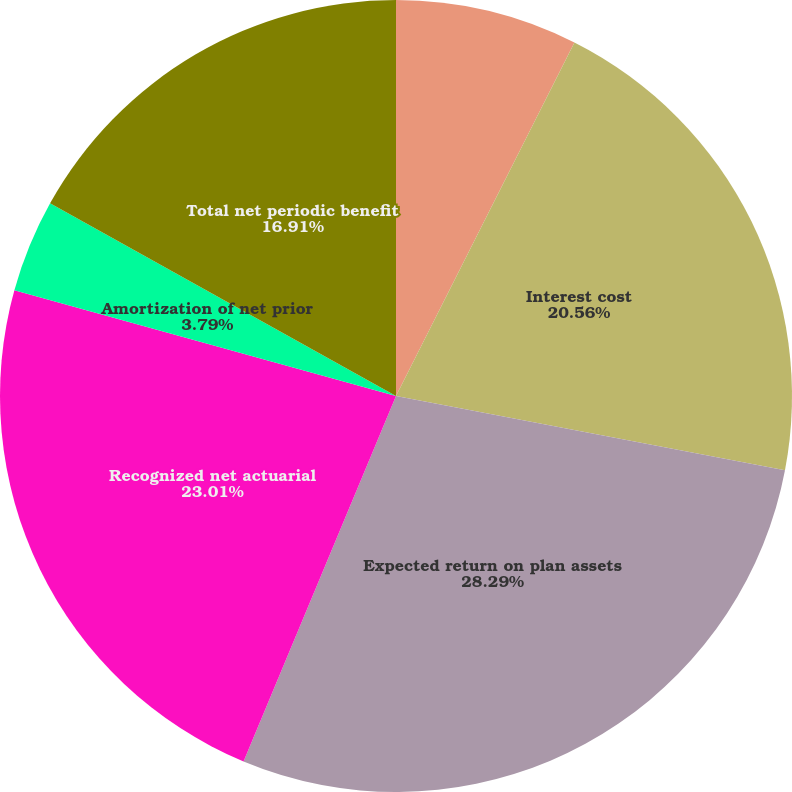Convert chart. <chart><loc_0><loc_0><loc_500><loc_500><pie_chart><fcel>Service cost<fcel>Interest cost<fcel>Expected return on plan assets<fcel>Recognized net actuarial<fcel>Amortization of net prior<fcel>Total net periodic benefit<nl><fcel>7.44%<fcel>20.56%<fcel>28.29%<fcel>23.01%<fcel>3.79%<fcel>16.91%<nl></chart> 